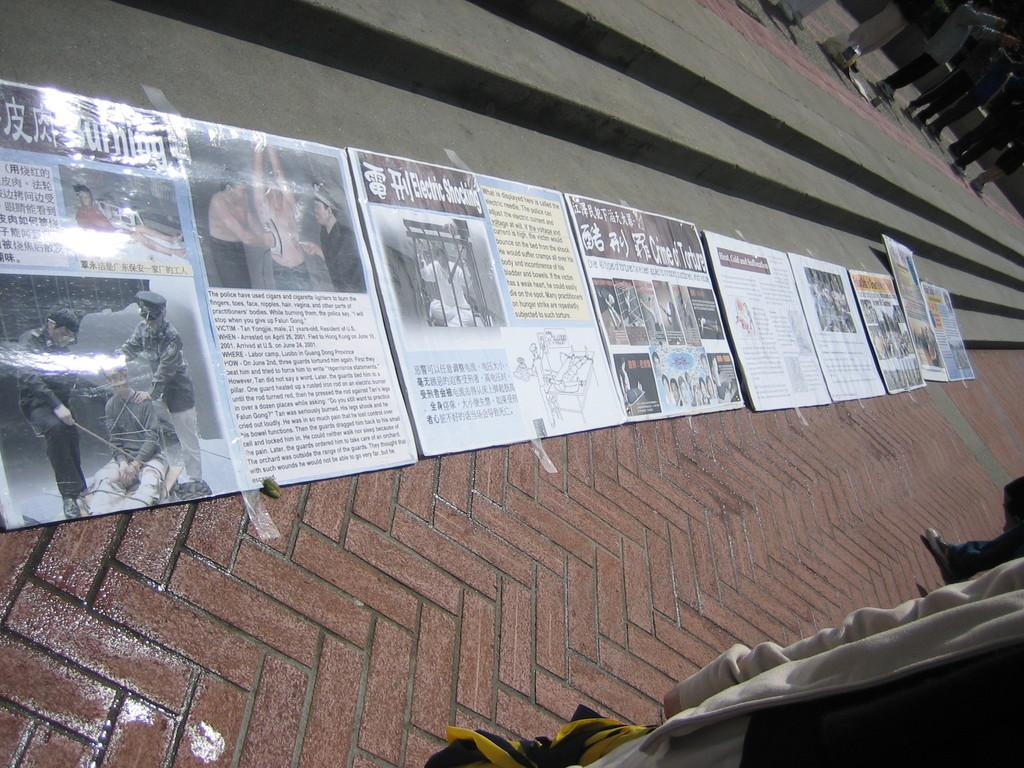What is located in the center of the image? There are posters in the center of the image. Where are the posters placed? The posters are on a wall. What type of memory is being stored in the posters? The posters do not store memory; they are visual displays on a wall. 